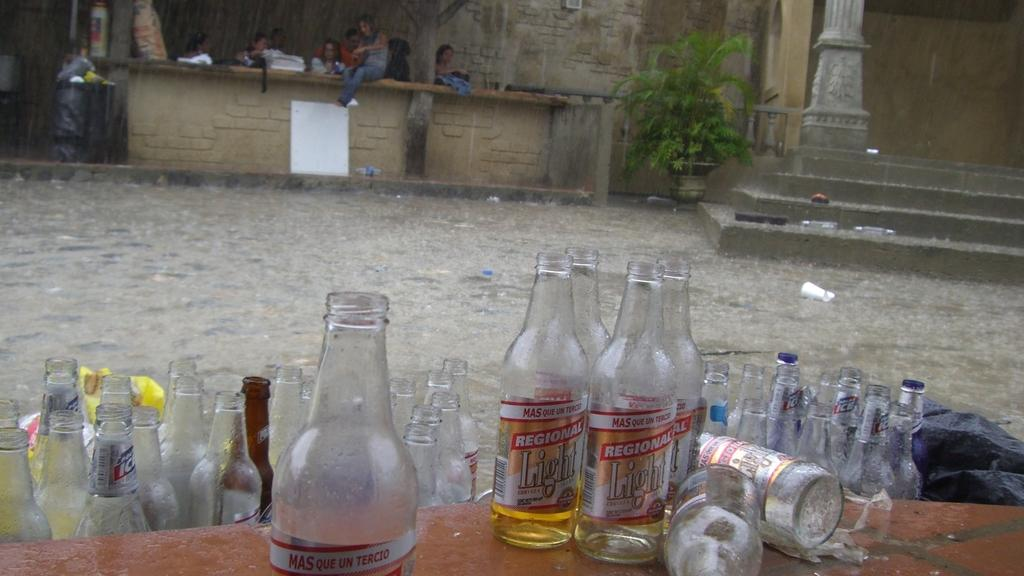<image>
Offer a succinct explanation of the picture presented. Empty bottles of Regional Light is next to other empty bottles. 